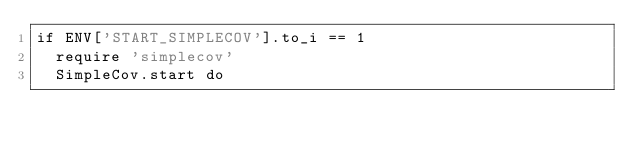Convert code to text. <code><loc_0><loc_0><loc_500><loc_500><_Ruby_>if ENV['START_SIMPLECOV'].to_i == 1
  require 'simplecov'
  SimpleCov.start do</code> 